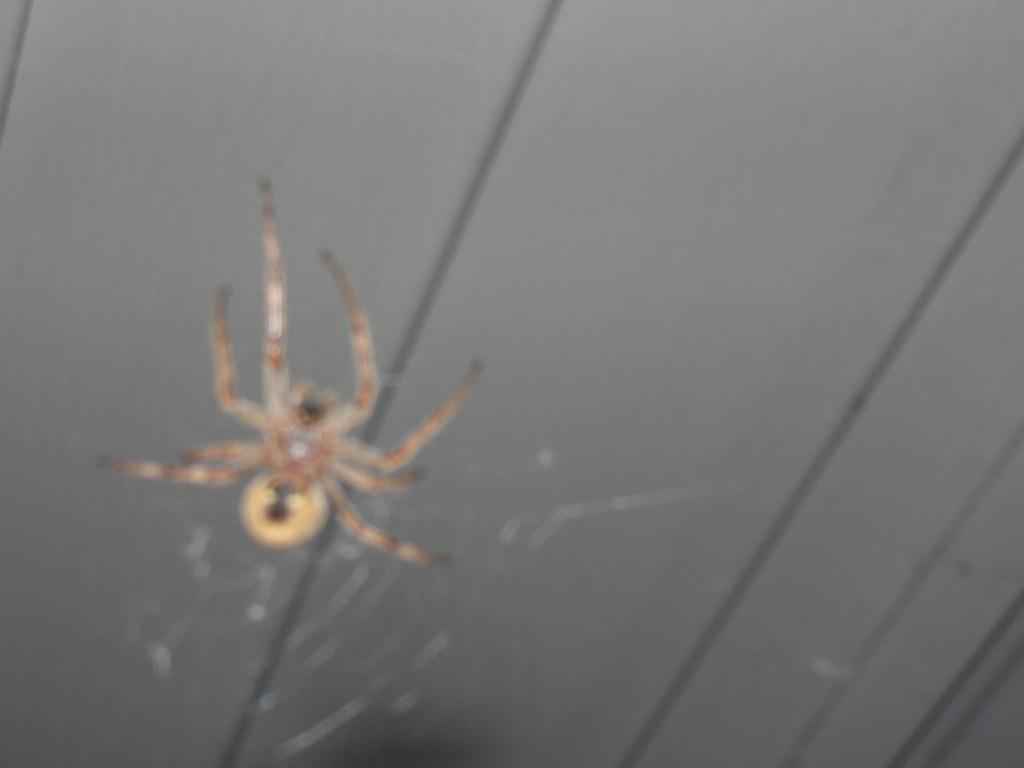What is the main subject of the image? There is a spider in the image. Where is the spider located? The spider is on a web. What is above the spider in the image? There is a ceiling above the spider. What type of treatment is the spider receiving in the image? There is no indication in the image that the spider is receiving any treatment. Can you tell me what request the spider is making in the image? There is no indication in the image that the spider is making any request. 